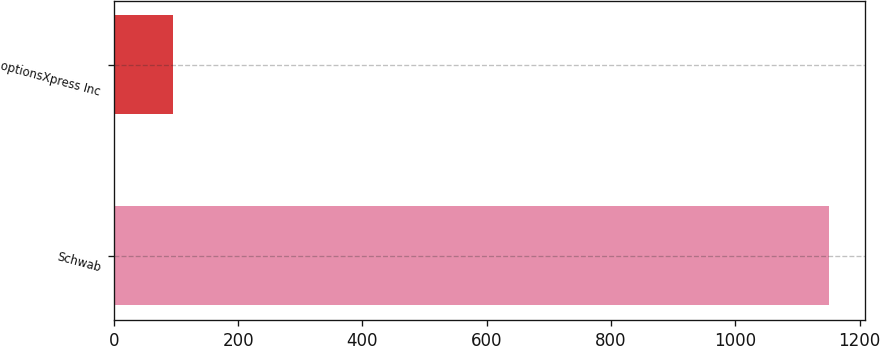Convert chart. <chart><loc_0><loc_0><loc_500><loc_500><bar_chart><fcel>Schwab<fcel>optionsXpress Inc<nl><fcel>1151<fcel>96<nl></chart> 